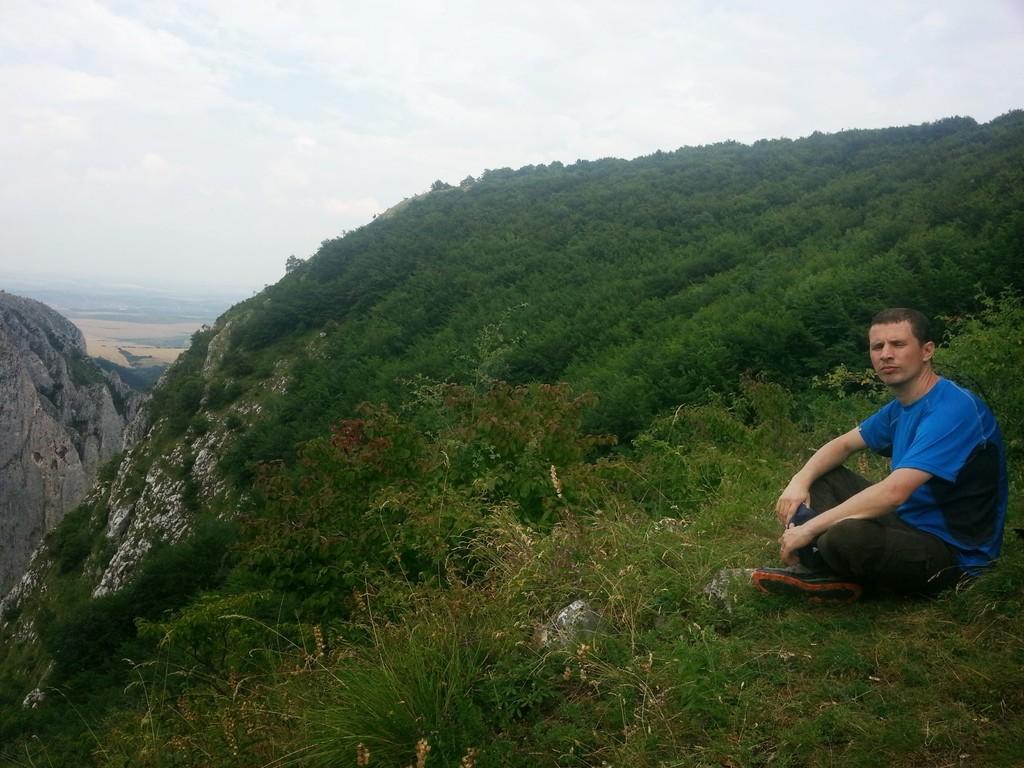Describe this image in one or two sentences. In this picture there is a man sitting on the ground at the right side. In the center there is grass on the ground, there are mountains in the background and the sky is cloudy. 